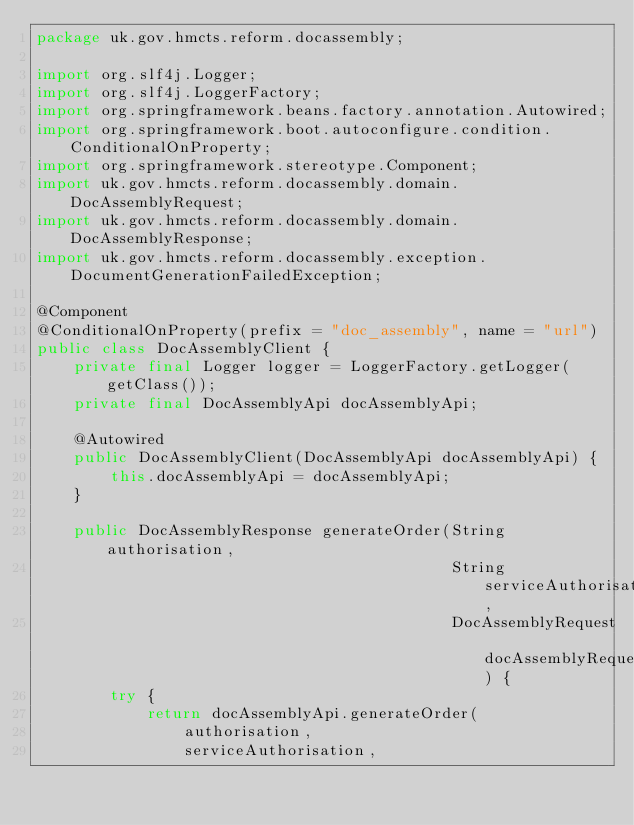<code> <loc_0><loc_0><loc_500><loc_500><_Java_>package uk.gov.hmcts.reform.docassembly;

import org.slf4j.Logger;
import org.slf4j.LoggerFactory;
import org.springframework.beans.factory.annotation.Autowired;
import org.springframework.boot.autoconfigure.condition.ConditionalOnProperty;
import org.springframework.stereotype.Component;
import uk.gov.hmcts.reform.docassembly.domain.DocAssemblyRequest;
import uk.gov.hmcts.reform.docassembly.domain.DocAssemblyResponse;
import uk.gov.hmcts.reform.docassembly.exception.DocumentGenerationFailedException;

@Component
@ConditionalOnProperty(prefix = "doc_assembly", name = "url")
public class DocAssemblyClient {
    private final Logger logger = LoggerFactory.getLogger(getClass());
    private final DocAssemblyApi docAssemblyApi;

    @Autowired
    public DocAssemblyClient(DocAssemblyApi docAssemblyApi) {
        this.docAssemblyApi = docAssemblyApi;
    }

    public DocAssemblyResponse generateOrder(String authorisation,
                                             String serviceAuthorisation,
                                             DocAssemblyRequest docAssemblyRequest) {
        try {
            return docAssemblyApi.generateOrder(
                authorisation,
                serviceAuthorisation,</code> 